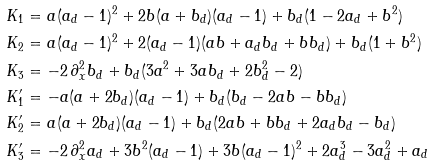<formula> <loc_0><loc_0><loc_500><loc_500>K _ { 1 } & = a ( a _ { d } - 1 ) ^ { 2 } + 2 b ( a + b _ { d } ) ( a _ { d } - 1 ) + b _ { d } ( 1 - 2 a _ { d } + b ^ { 2 } ) \\ K _ { 2 } & = a ( a _ { d } - 1 ) ^ { 2 } + 2 ( a _ { d } - 1 ) ( a b + a _ { d } b _ { d } + b b _ { d } ) + b _ { d } ( 1 + b ^ { 2 } ) \\ K _ { 3 } & = - 2 \, \partial _ { x } ^ { 2 } b _ { d } + b _ { d } ( 3 a ^ { 2 } + 3 a b _ { d } + 2 b _ { d } ^ { 2 } - 2 ) \\ K ^ { \prime } _ { 1 } & = - a ( a + 2 b _ { d } ) ( a _ { d } - 1 ) + b _ { d } ( b _ { d } - 2 a b - b b _ { d } ) \\ K ^ { \prime } _ { 2 } & = a ( a + 2 b _ { d } ) ( a _ { d } - 1 ) + b _ { d } ( 2 a b + b b _ { d } + 2 a _ { d } b _ { d } - b _ { d } ) \\ K ^ { \prime } _ { 3 } & = - 2 \, \partial _ { x } ^ { 2 } a _ { d } + 3 b ^ { 2 } ( a _ { d } - 1 ) + 3 b ( a _ { d } - 1 ) ^ { 2 } + 2 a _ { d } ^ { 3 } - 3 a _ { d } ^ { 2 } + a _ { d }</formula> 